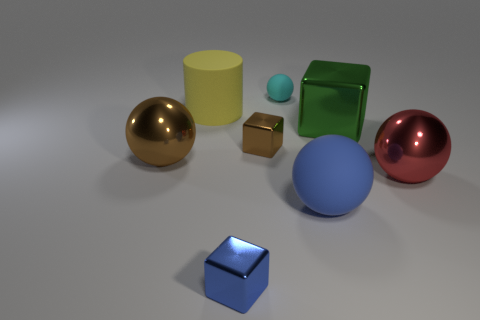Add 1 brown shiny blocks. How many objects exist? 9 Subtract all cylinders. How many objects are left? 7 Subtract 0 yellow balls. How many objects are left? 8 Subtract all small blue cubes. Subtract all big cyan shiny cylinders. How many objects are left? 7 Add 3 small cyan matte spheres. How many small cyan matte spheres are left? 4 Add 5 red spheres. How many red spheres exist? 6 